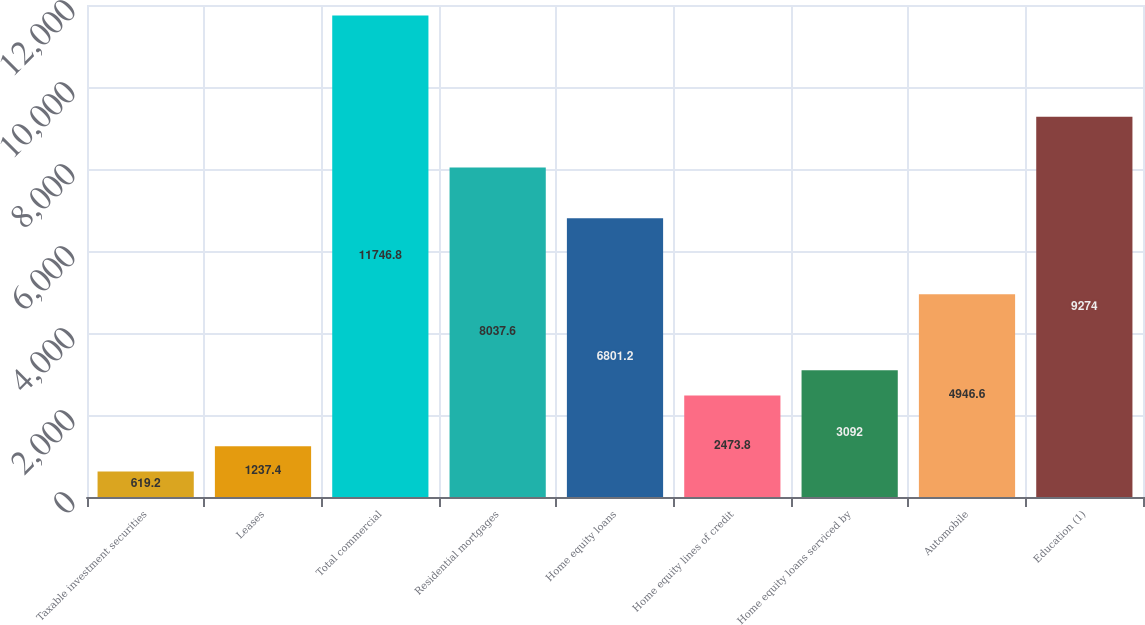<chart> <loc_0><loc_0><loc_500><loc_500><bar_chart><fcel>Taxable investment securities<fcel>Leases<fcel>Total commercial<fcel>Residential mortgages<fcel>Home equity loans<fcel>Home equity lines of credit<fcel>Home equity loans serviced by<fcel>Automobile<fcel>Education (1)<nl><fcel>619.2<fcel>1237.4<fcel>11746.8<fcel>8037.6<fcel>6801.2<fcel>2473.8<fcel>3092<fcel>4946.6<fcel>9274<nl></chart> 